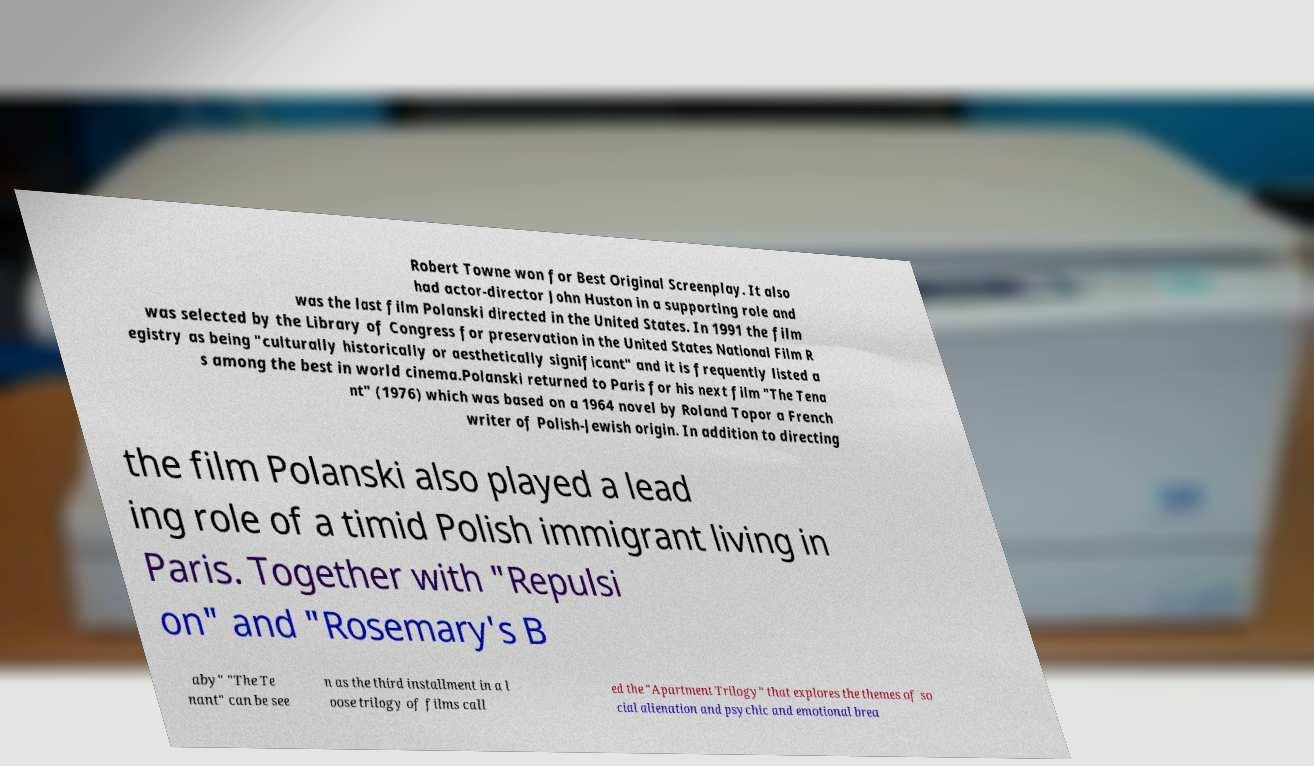Can you accurately transcribe the text from the provided image for me? Robert Towne won for Best Original Screenplay. It also had actor-director John Huston in a supporting role and was the last film Polanski directed in the United States. In 1991 the film was selected by the Library of Congress for preservation in the United States National Film R egistry as being "culturally historically or aesthetically significant" and it is frequently listed a s among the best in world cinema.Polanski returned to Paris for his next film "The Tena nt" (1976) which was based on a 1964 novel by Roland Topor a French writer of Polish-Jewish origin. In addition to directing the film Polanski also played a lead ing role of a timid Polish immigrant living in Paris. Together with "Repulsi on" and "Rosemary's B aby" "The Te nant" can be see n as the third installment in a l oose trilogy of films call ed the "Apartment Trilogy" that explores the themes of so cial alienation and psychic and emotional brea 